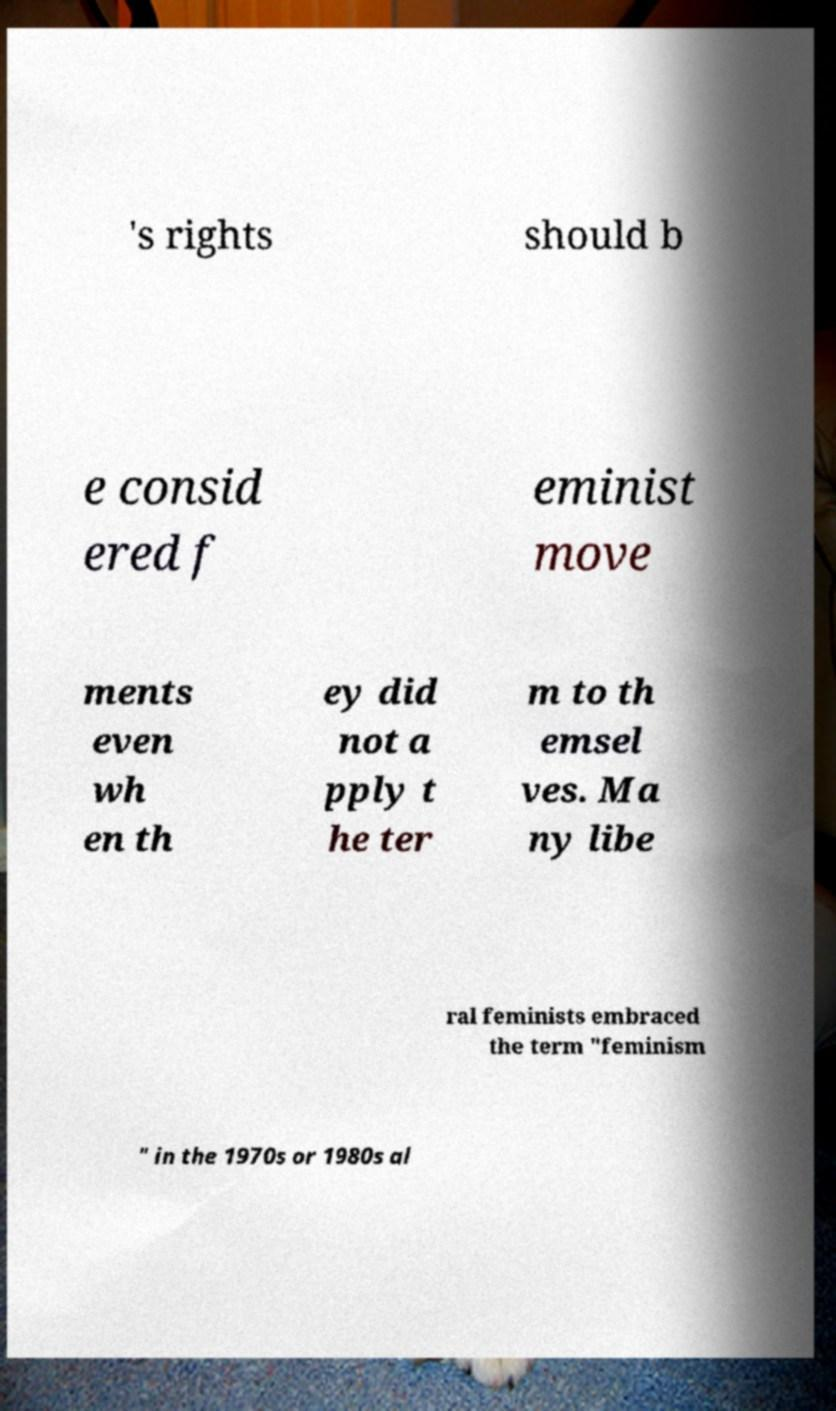Can you accurately transcribe the text from the provided image for me? 's rights should b e consid ered f eminist move ments even wh en th ey did not a pply t he ter m to th emsel ves. Ma ny libe ral feminists embraced the term "feminism " in the 1970s or 1980s al 